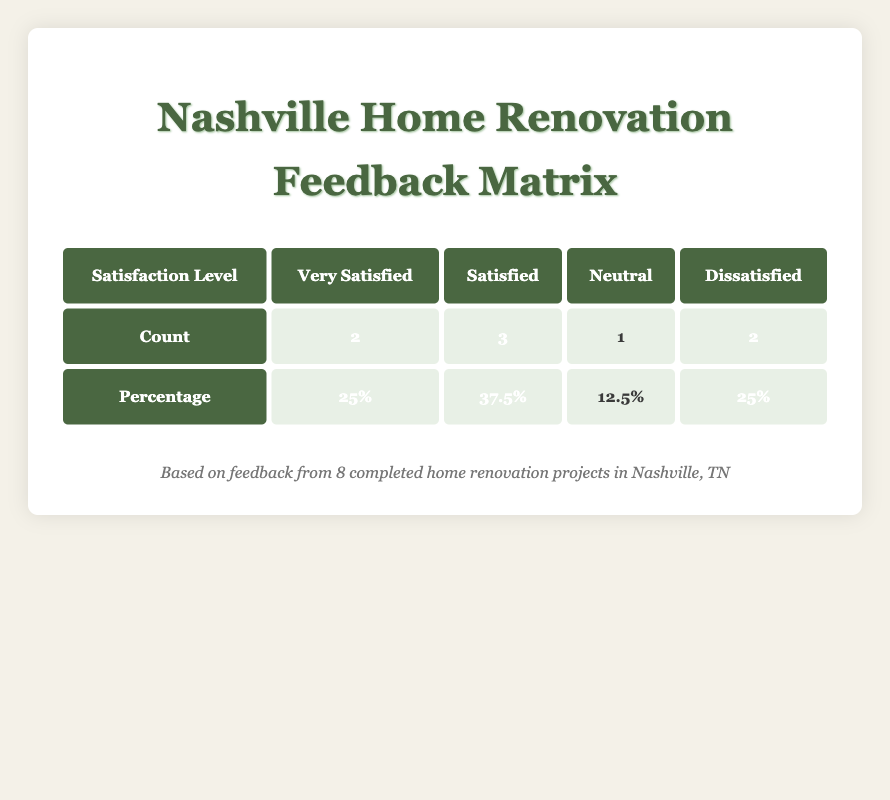What is the count of customers who were very satisfied? The table lists two counts under the "Very Satisfied" category, so we simply refer to that number for the answer.
Answer: 2 How many customers reported a neutral satisfaction level? The table includes one count under the "Neutral" category, indicating that one customer experienced neutrality in their satisfaction.
Answer: 1 What percentage of the customers were dissatisfied? The percentage of dissatisfied customers is given as 25%, directly from the table.
Answer: 25% What is the difference in counts between satisfied and very satisfied customers? The table states that there are 3 satisfied customers and 2 very satisfied customers. The difference is calculated as 3 - 2 = 1.
Answer: 1 Is the majority of customers satisfied or dissatisfied? To evaluate this, we see that 3 are satisfied compared to 2 who are dissatisfied; therefore, the majority is satisfied.
Answer: Yes What is the average percentage of customers who are satisfied or very satisfied? The percentages are 37.5% for satisfied and 25% for very satisfied. To find the average: (37.5 + 25) / 2 = 31.25%.
Answer: 31.25% Are more customers very satisfied than neutral? There are 2 customers in the very satisfied category and 1 customer in the neutral category. Therefore, more customers are very satisfied than neutral.
Answer: Yes What is the total number of customers who provided feedback? The table provides counts for four satisfaction levels, adding up to 8 customers (2 very satisfied + 3 satisfied + 1 neutral + 2 dissatisfied).
Answer: 8 Is the satisfaction level of anyone categorized as neutral higher than any dissatisfied ratings? The neutral satisfaction level is represented by 1 customer; meanwhile, there are 2 customers dissatisfied. Therefore, the neutral level is not higher than dissatisfied.
Answer: No 